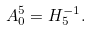Convert formula to latex. <formula><loc_0><loc_0><loc_500><loc_500>A ^ { 5 } _ { 0 } = H _ { 5 } ^ { - 1 } .</formula> 